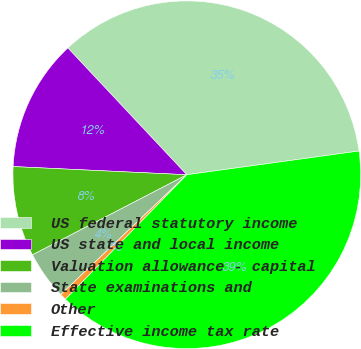Convert chart to OTSL. <chart><loc_0><loc_0><loc_500><loc_500><pie_chart><fcel>US federal statutory income<fcel>US state and local income<fcel>Valuation allowance - capital<fcel>State examinations and<fcel>Other<fcel>Effective income tax rate<nl><fcel>34.81%<fcel>12.26%<fcel>8.37%<fcel>4.48%<fcel>0.6%<fcel>39.48%<nl></chart> 